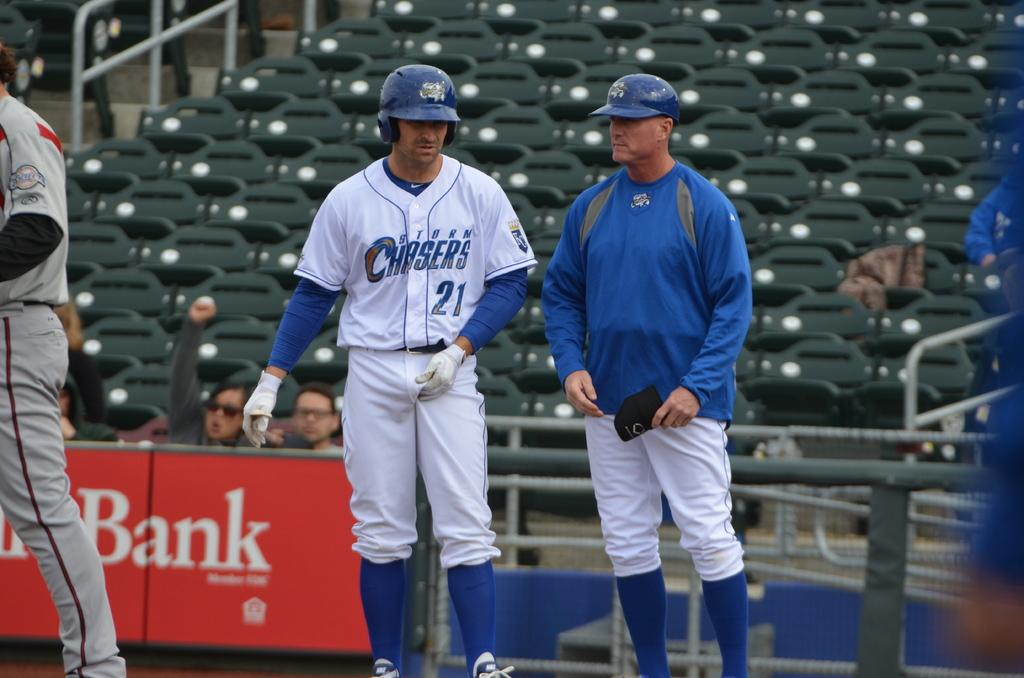<image>
Provide a brief description of the given image. Baseball player wearing a jersey which says Chasers on it. 